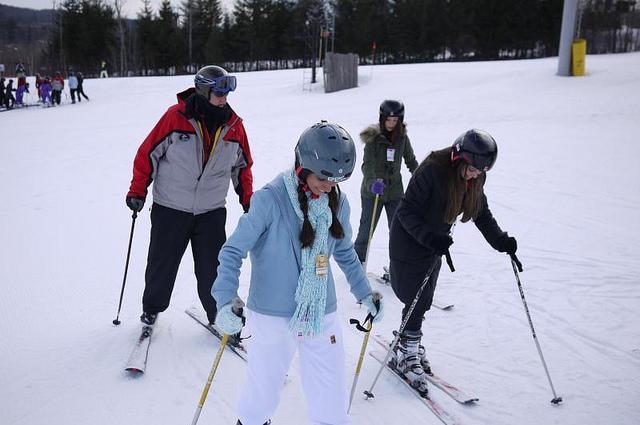How many poles are there?
Give a very brief answer. 6. How many women are in the image?
Give a very brief answer. 4. How many people are visible?
Give a very brief answer. 4. How many glass cups have water in them?
Give a very brief answer. 0. 